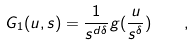Convert formula to latex. <formula><loc_0><loc_0><loc_500><loc_500>G _ { 1 } ( { u } , s ) = \frac { 1 } { s ^ { d \delta } } g ( \frac { u } { s ^ { \delta } } ) \quad ,</formula> 